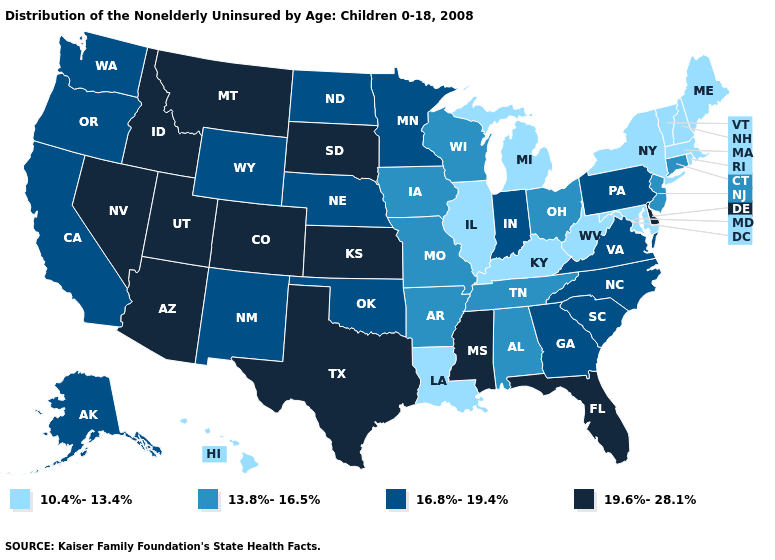What is the value of Idaho?
Write a very short answer. 19.6%-28.1%. What is the value of Arizona?
Be succinct. 19.6%-28.1%. Which states have the lowest value in the USA?
Keep it brief. Hawaii, Illinois, Kentucky, Louisiana, Maine, Maryland, Massachusetts, Michigan, New Hampshire, New York, Rhode Island, Vermont, West Virginia. Which states hav the highest value in the West?
Quick response, please. Arizona, Colorado, Idaho, Montana, Nevada, Utah. What is the value of Louisiana?
Be succinct. 10.4%-13.4%. What is the value of New Jersey?
Short answer required. 13.8%-16.5%. Among the states that border Virginia , does North Carolina have the highest value?
Write a very short answer. Yes. What is the lowest value in the USA?
Quick response, please. 10.4%-13.4%. Does Nebraska have a higher value than Nevada?
Short answer required. No. Name the states that have a value in the range 16.8%-19.4%?
Give a very brief answer. Alaska, California, Georgia, Indiana, Minnesota, Nebraska, New Mexico, North Carolina, North Dakota, Oklahoma, Oregon, Pennsylvania, South Carolina, Virginia, Washington, Wyoming. Name the states that have a value in the range 13.8%-16.5%?
Give a very brief answer. Alabama, Arkansas, Connecticut, Iowa, Missouri, New Jersey, Ohio, Tennessee, Wisconsin. Name the states that have a value in the range 10.4%-13.4%?
Quick response, please. Hawaii, Illinois, Kentucky, Louisiana, Maine, Maryland, Massachusetts, Michigan, New Hampshire, New York, Rhode Island, Vermont, West Virginia. Name the states that have a value in the range 19.6%-28.1%?
Concise answer only. Arizona, Colorado, Delaware, Florida, Idaho, Kansas, Mississippi, Montana, Nevada, South Dakota, Texas, Utah. Does the first symbol in the legend represent the smallest category?
Short answer required. Yes. Does South Dakota have the highest value in the USA?
Be succinct. Yes. 